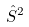<formula> <loc_0><loc_0><loc_500><loc_500>\hat { S } ^ { 2 }</formula> 